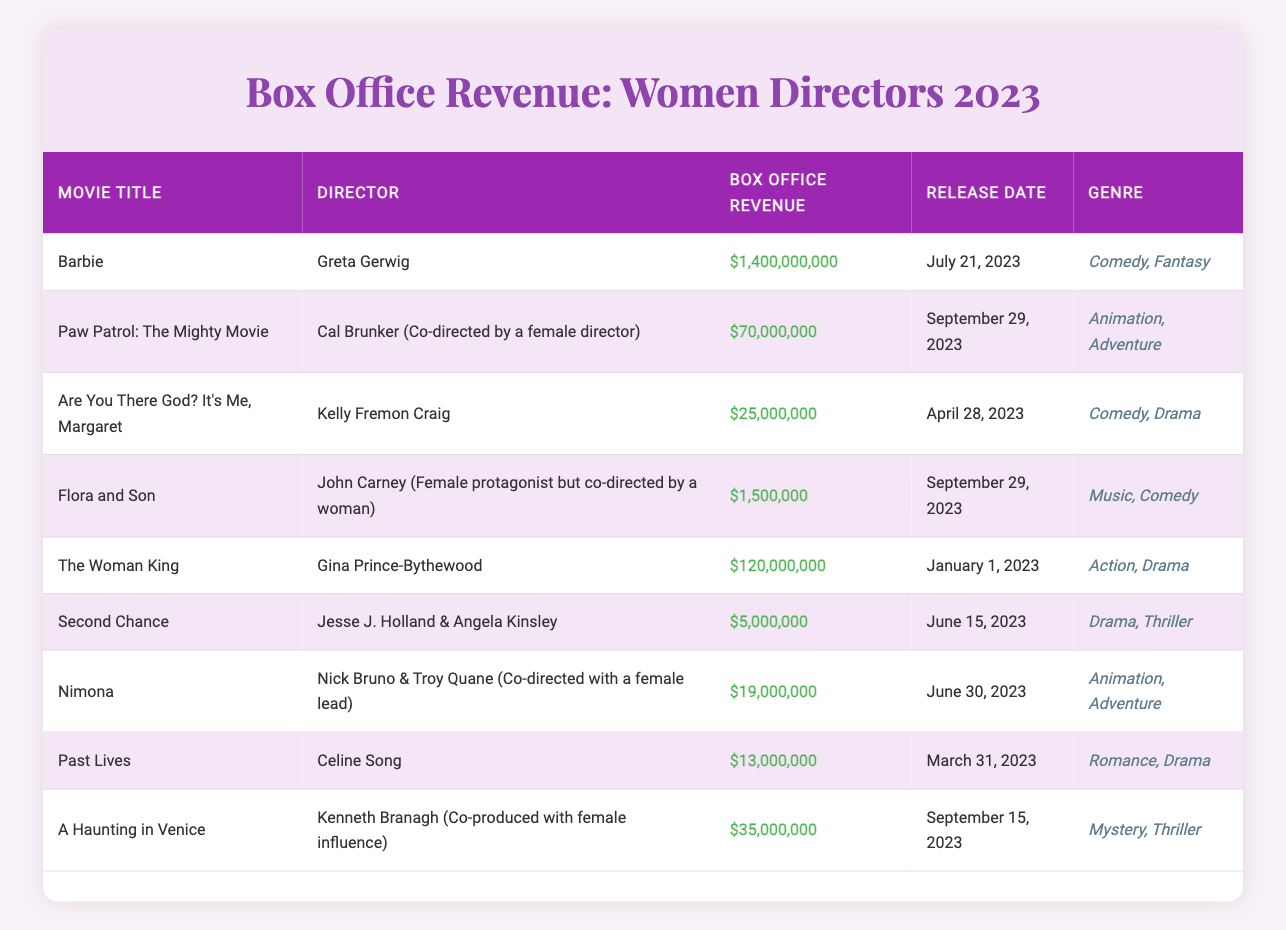What is the box office revenue of "Barbie"? The table lists "Barbie" with a box office revenue of $1,400,000,000.
Answer: $1,400,000,000 Which movie had the lowest box office revenue? The table shows "Flora and Son" with the lowest revenue of $1,500,000.
Answer: $1,500,000 How many movies directed by women earned over $100 million at the box office? "Barbie" ($1,400,000,000) and "The Woman King" ($120,000,000) are the only two that exceed $100 million. Therefore, there are 2 movies.
Answer: 2 What is the total box office revenue for all the movies listed? Adding the revenues: $1,400,000,000 + $70,000,000 + $25,000,000 + $1,500,000 + $120,000,000 + $5,000,000 + $19,000,000 + $13,000,000 + $35,000,000 = $1,663,500,000.
Answer: $1,663,500,000 Which director has the highest-grossing film among the listed movies? Greta Gerwig directed "Barbie," which has the highest box office revenue at $1,400,000,000.
Answer: Greta Gerwig Is "A Haunting in Venice" directed by a woman? The table indicates that "A Haunting in Venice" is directed by Kenneth Branagh, and it mentions female influence but does not credit a female director, so the answer is no.
Answer: No What is the average box office revenue for the movies directed or co-directed by women? The total revenue for relevant movies is $1,400,000,000 (Barbie) + $70,000,000 (Paw Patrol) + $25,000,000 (Are You There God?) + $120,000,000 (The Woman King) + $5,000,000 (Second Chance) + $19,000,000 (Nimona) + $13,000,000 (Past Lives) = $1,682,000,000. Divided by 7 movies, the average revenue is $1,682,000,000 / 7 = $240,285,714.29.
Answer: $240,285,714.29 Which movie genres are represented in films directed by women? The genres listed in the table include Comedy, Fantasy, Animation, Adventure, Action, Drama, Music, and Thriller, all represented in the films directed by women and their co-directors.
Answer: Comedy, Fantasy, Animation, Adventure, Action, Drama, Music, Thriller What was the release date of the highest-grossing movie? The highest-grossing movie is "Barbie," which was released on July 21, 2023.
Answer: July 21, 2023 Did any films directed by women break the $200 million mark? The only film that broke the $200 million mark is "Barbie," which grossed $1,400,000,000, thus it is true that there was at least one such film.
Answer: Yes 